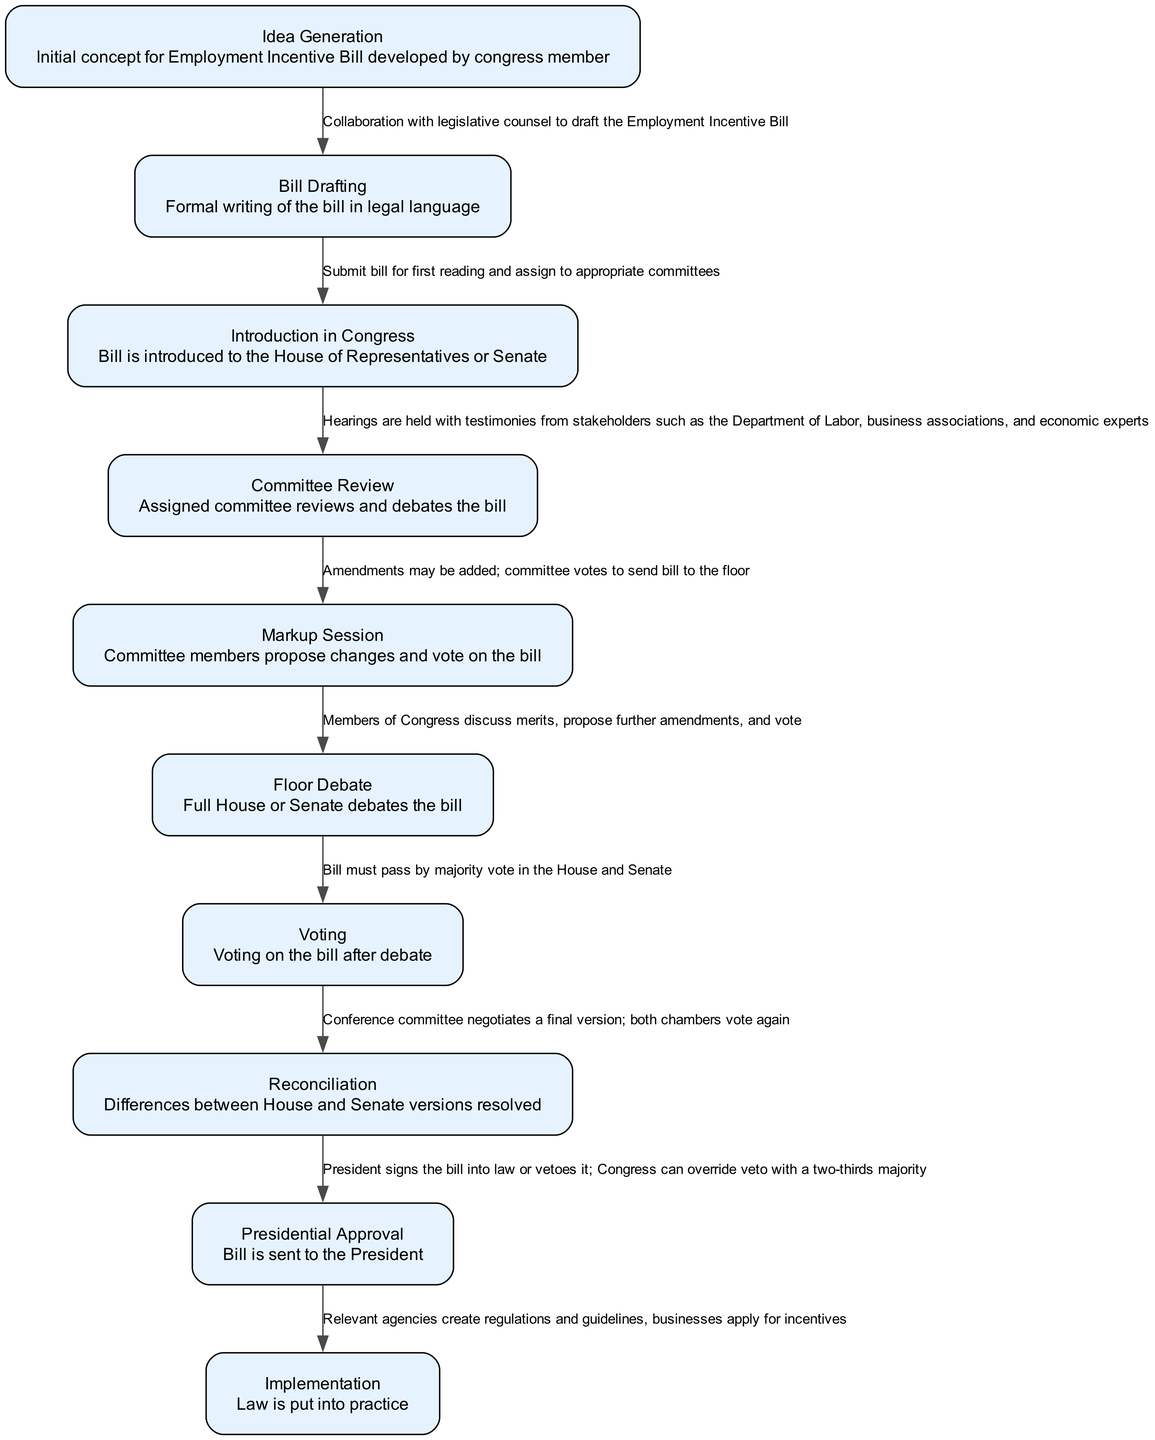What is the first step in the legislative process for the Employment Incentive Bill? The first step is "Idea Generation," where the initial concept for the bill is developed by a congress member. This stage initiates the legislative process and sets the groundwork for subsequent steps.
Answer: Idea Generation How many steps are there in the legislative process for the Employment Incentive Bill? By counting the nodes listed in the diagram, there are ten distinct steps outlined in the process of the Employment Incentive Bill. This includes all activities from idea generation to implementation.
Answer: 10 What is the action associated with the "Committee Review" step? The action for "Committee Review" involves holding hearings with testimonies from various stakeholders including the Department of Labor and economic experts to assess the bill's impact. This step is crucial for gathering information and feedback.
Answer: Hearings are held with testimonies from stakeholders such as the Department of Labor, business associations, and economic experts Which step follows "Voting" in the legislative process? After the "Voting" step, which involves passing the bill by majority vote, the next step is "Reconciliation," where differences between the House and Senate versions of the bill are resolved. This ensures a unified approach to the legislation.
Answer: Reconciliation What is the final step in the process outlined in the diagram? The final step in the legislative process for the Employment Incentive Bill is "Implementation," where the law is put into practice by relevant agencies creating regulations and guidelines needed for businesses to apply for incentives.
Answer: Implementation What is the purpose of the "Markup Session"? The "Markup Session" allows committee members to propose changes to the bill, discuss amendments, and conduct a vote on whether to send the bill to the floor for further debate. This is essential for refining the legislation.
Answer: Amendments may be added; committee votes to send bill to the floor Which step is characterized by debate among the full House or Senate? The "Floor Debate" step is where the full House or Senate debates the bill, discussing its merits and any proposed amendments, making it a critical phase for legislators to express their positions before a vote.
Answer: Floor Debate What action takes place during "Presidential Approval"? During "Presidential Approval," the bill is sent to the President to be signed into law or vetoed. If vetoed, Congress has the option to override the veto with a two-thirds majority vote, which highlights the checks and balances in the legislative process.
Answer: President signs the bill into law or vetoes it; Congress can override veto with a two-thirds majority 